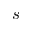Convert formula to latex. <formula><loc_0><loc_0><loc_500><loc_500>s</formula> 